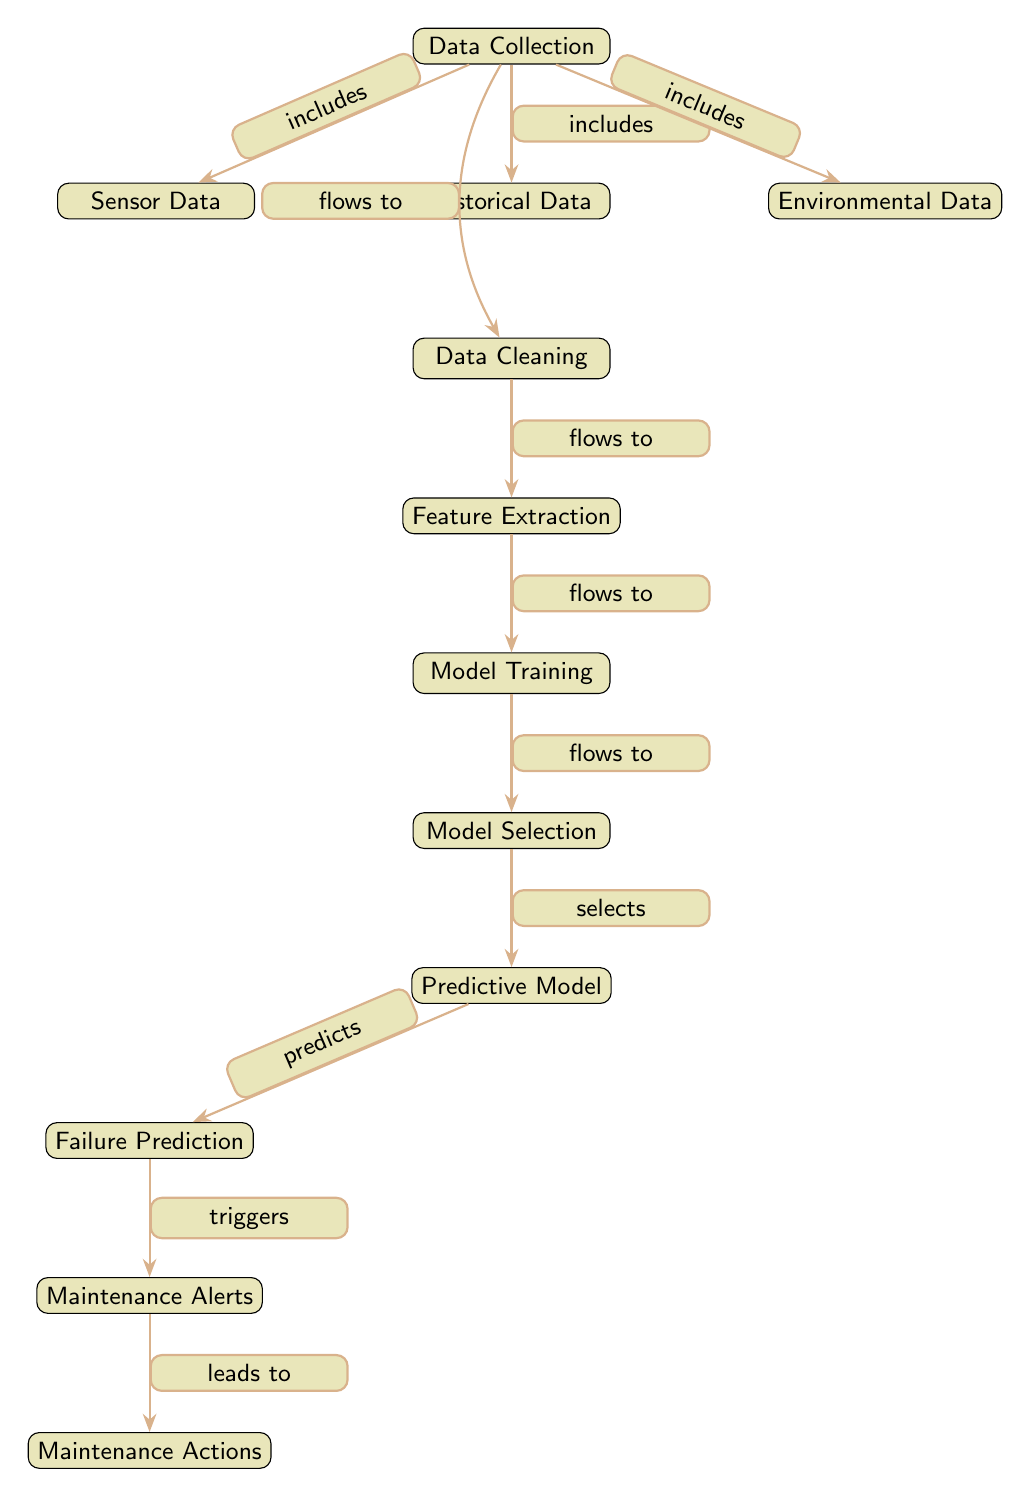What is the first step in the predictive maintenance process? The first step in the predictive maintenance process is 'Data Collection', as indicated at the top of the diagram.
Answer: Data Collection How many types of data are mentioned in the diagram? The diagram mentions three types of data: Sensor Data, Historical Data, and Environmental Data.
Answer: Three What action follows feature extraction in the process? The action that follows feature extraction is 'Model Training', which is directly connected below feature extraction in the diagram.
Answer: Model Training Which component generates maintenance alerts? The component that generates maintenance alerts is 'Failure Prediction', as it predicts failures and triggers maintenance alerts based on that prediction.
Answer: Failure Prediction What is the relationship between model training and model selection? The relationship is that 'Model Training' flows to 'Model Selection', indicating that model selection occurs after model training.
Answer: Flows to How does environmental data fit into the data collection process? Environmental data is one of the three types included in the 'Data Collection', meaning it contributes to the overall data gathered for analysis.
Answer: Includes Which step leads to maintenance actions? The step leading to maintenance actions is 'Maintenance Alerts', as indicated by the arrow that shows maintenance alerts trigger the subsequent maintenance actions.
Answer: Maintenance Alerts What does the predictive model specifically do in this process? The predictive model specifically 'predicts' failures, as indicated in its direct connection to the 'Failure Prediction' component.
Answer: Predicts How many edges are depicted in the diagram? There are nine edges depicted in the diagram, connecting all the nodes in the predictive maintenance process.
Answer: Nine 